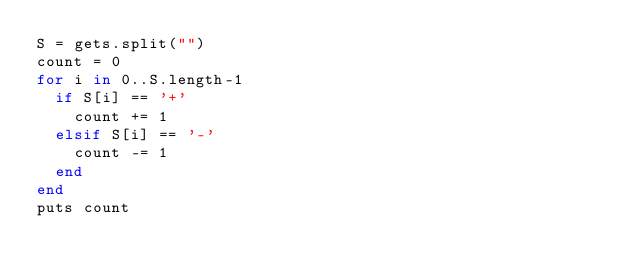Convert code to text. <code><loc_0><loc_0><loc_500><loc_500><_Ruby_>S = gets.split("")
count = 0
for i in 0..S.length-1
  if S[i] == '+'
    count += 1
  elsif S[i] == '-'
    count -= 1
  end
end
puts count</code> 